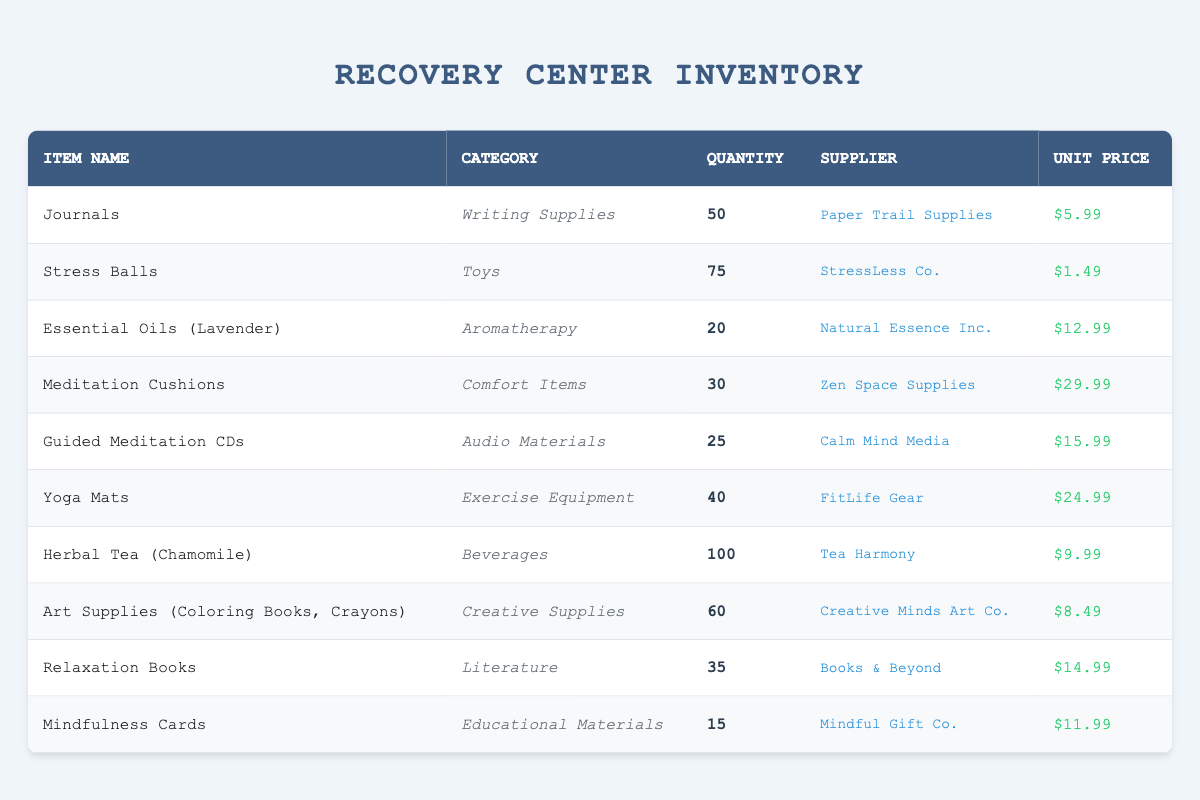What item has the highest quantity available? Looking at the "quantity available" column, the item with the highest quantity is "Herbal Tea (Chamomile)" with 100 available.
Answer: Herbal Tea (Chamomile) How many meditation-related items are in the inventory? To find meditation-related items, we look for items in the categories that suggest meditation or relaxation. These are "Meditation Cushions" and "Guided Meditation CDs", giving us a total of 2 items.
Answer: 2 What is the total quantity of all writing supplies? The only writing supply listed is "Journals" with a quantity of 50. Since that is the only relevant item, the total is 50.
Answer: 50 Which supplier provides the most items? By checking the supplier for each item, we find that "Tea Harmony" supplies 1 item, while "Creative Minds Art Co." supplies 1 item, and "StressLess Co." supplies 1 item. Since no supplier stands out with more items, all have the same count—two items each.
Answer: None stands out What is the average unit price of stress-relief items? To calculate the average unit price, we first find the total unit prices: 5.99, 1.49, 12.99, 29.99, 15.99, 24.99, 9.99, 8.49, 14.99, 11.99. Summing these gives us a total price of 149.91 for 10 items. Then we divide 149.91 by 10 to get an average of 14.99.
Answer: 14.99 Are there more toys or beverages in the inventory? The inventory shows 2 items under "Toys" (Stress Balls) and 1 item under "Beverages" (Herbal Tea). Thus, there are more toys than beverages in the inventory.
Answer: Yes How many items are priced above $20? The items priced above $20 are "Meditation Cushions" at $29.99 and "Yoga Mats" at $24.99, totaling 2 items that meet the price criteria.
Answer: 2 What is the total number of creative supplies available? The inventory lists "Art Supplies (Coloring Books, Crayons)" under creative supplies with a quantity of 60. Thus, the total number of creative supplies available is 60.
Answer: 60 Is there an essential oil available? Yes, there is "Essential Oils (Lavender)" listed under aromatherapy, confirming the availability of essential oils.
Answer: Yes What category has the lowest quantity of items available? By checking the quantity for each category, "Mindfulness Cards" has the lowest quantity of 15. Thus, the category with the lowest quantity is Educational Materials.
Answer: Educational Materials 